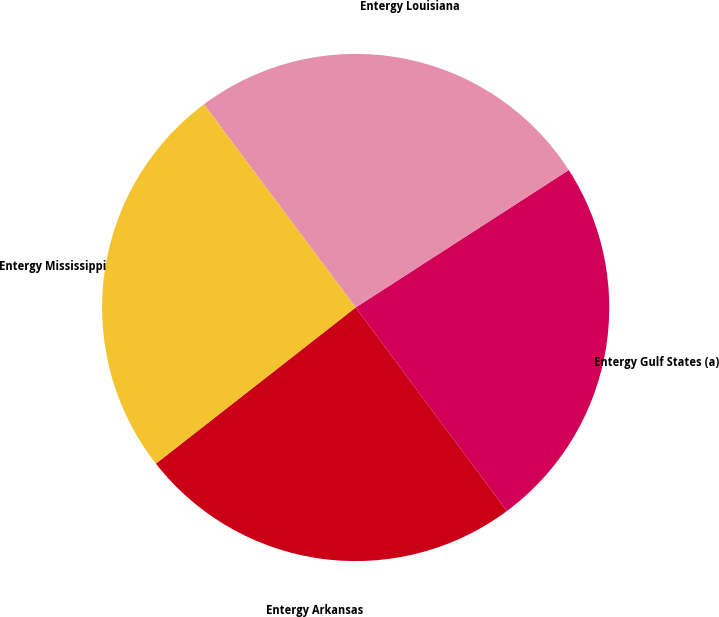Convert chart. <chart><loc_0><loc_0><loc_500><loc_500><pie_chart><fcel>Entergy Arkansas<fcel>Entergy Gulf States (a)<fcel>Entergy Louisiana<fcel>Entergy Mississippi<nl><fcel>24.61%<fcel>23.95%<fcel>26.09%<fcel>25.35%<nl></chart> 